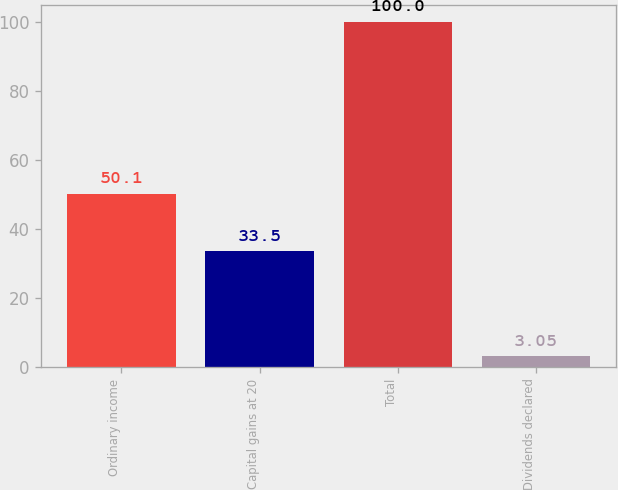<chart> <loc_0><loc_0><loc_500><loc_500><bar_chart><fcel>Ordinary income<fcel>Capital gains at 20<fcel>Total<fcel>Dividends declared<nl><fcel>50.1<fcel>33.5<fcel>100<fcel>3.05<nl></chart> 